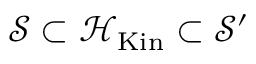<formula> <loc_0><loc_0><loc_500><loc_500>{ \mathcal { S } } \subset { \mathcal { H } } _ { K i n } \subset { \mathcal { S } } ^ { \prime }</formula> 